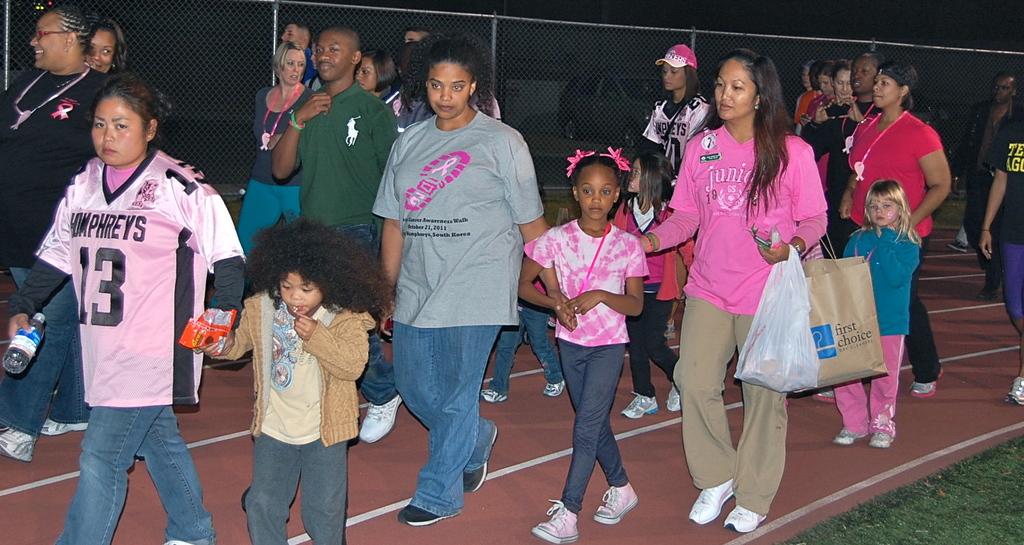What store is on the brown bag?
Provide a short and direct response. First choice. 